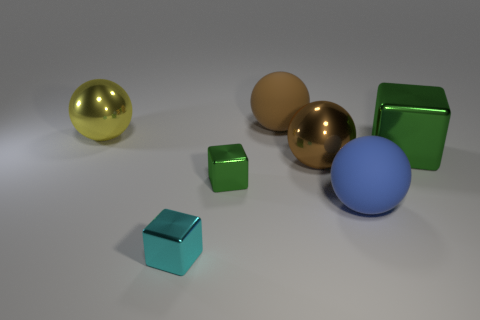What number of other objects are the same color as the large cube?
Your answer should be very brief. 1. There is a green object that is the same size as the brown metal ball; what is its material?
Your answer should be compact. Metal. What is the shape of the big thing that is on the left side of the brown shiny sphere and right of the small cyan object?
Your response must be concise. Sphere. There is a thing left of the tiny cyan metal thing; what is its color?
Ensure brevity in your answer.  Yellow. There is a cube that is both behind the blue ball and to the left of the brown rubber ball; what size is it?
Your response must be concise. Small. Are the tiny green object and the green block right of the small green thing made of the same material?
Your answer should be very brief. Yes. What number of large green metal things have the same shape as the small cyan thing?
Your answer should be very brief. 1. There is another block that is the same color as the big shiny block; what material is it?
Your answer should be very brief. Metal. How many small gray rubber objects are there?
Give a very brief answer. 0. There is a large blue object; does it have the same shape as the rubber object behind the large green thing?
Offer a very short reply. Yes. 